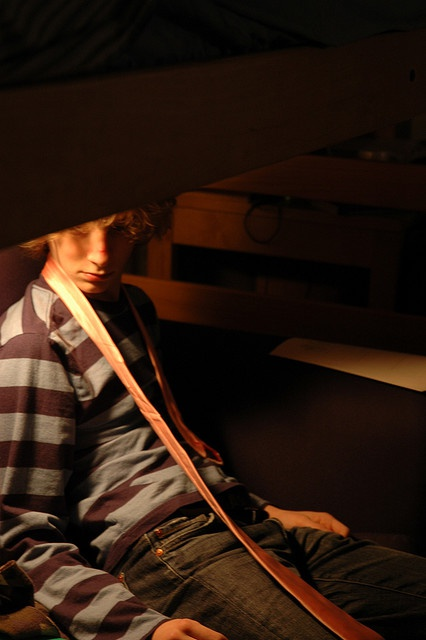Describe the objects in this image and their specific colors. I can see people in black, maroon, and gray tones and tie in black, maroon, orange, and khaki tones in this image. 